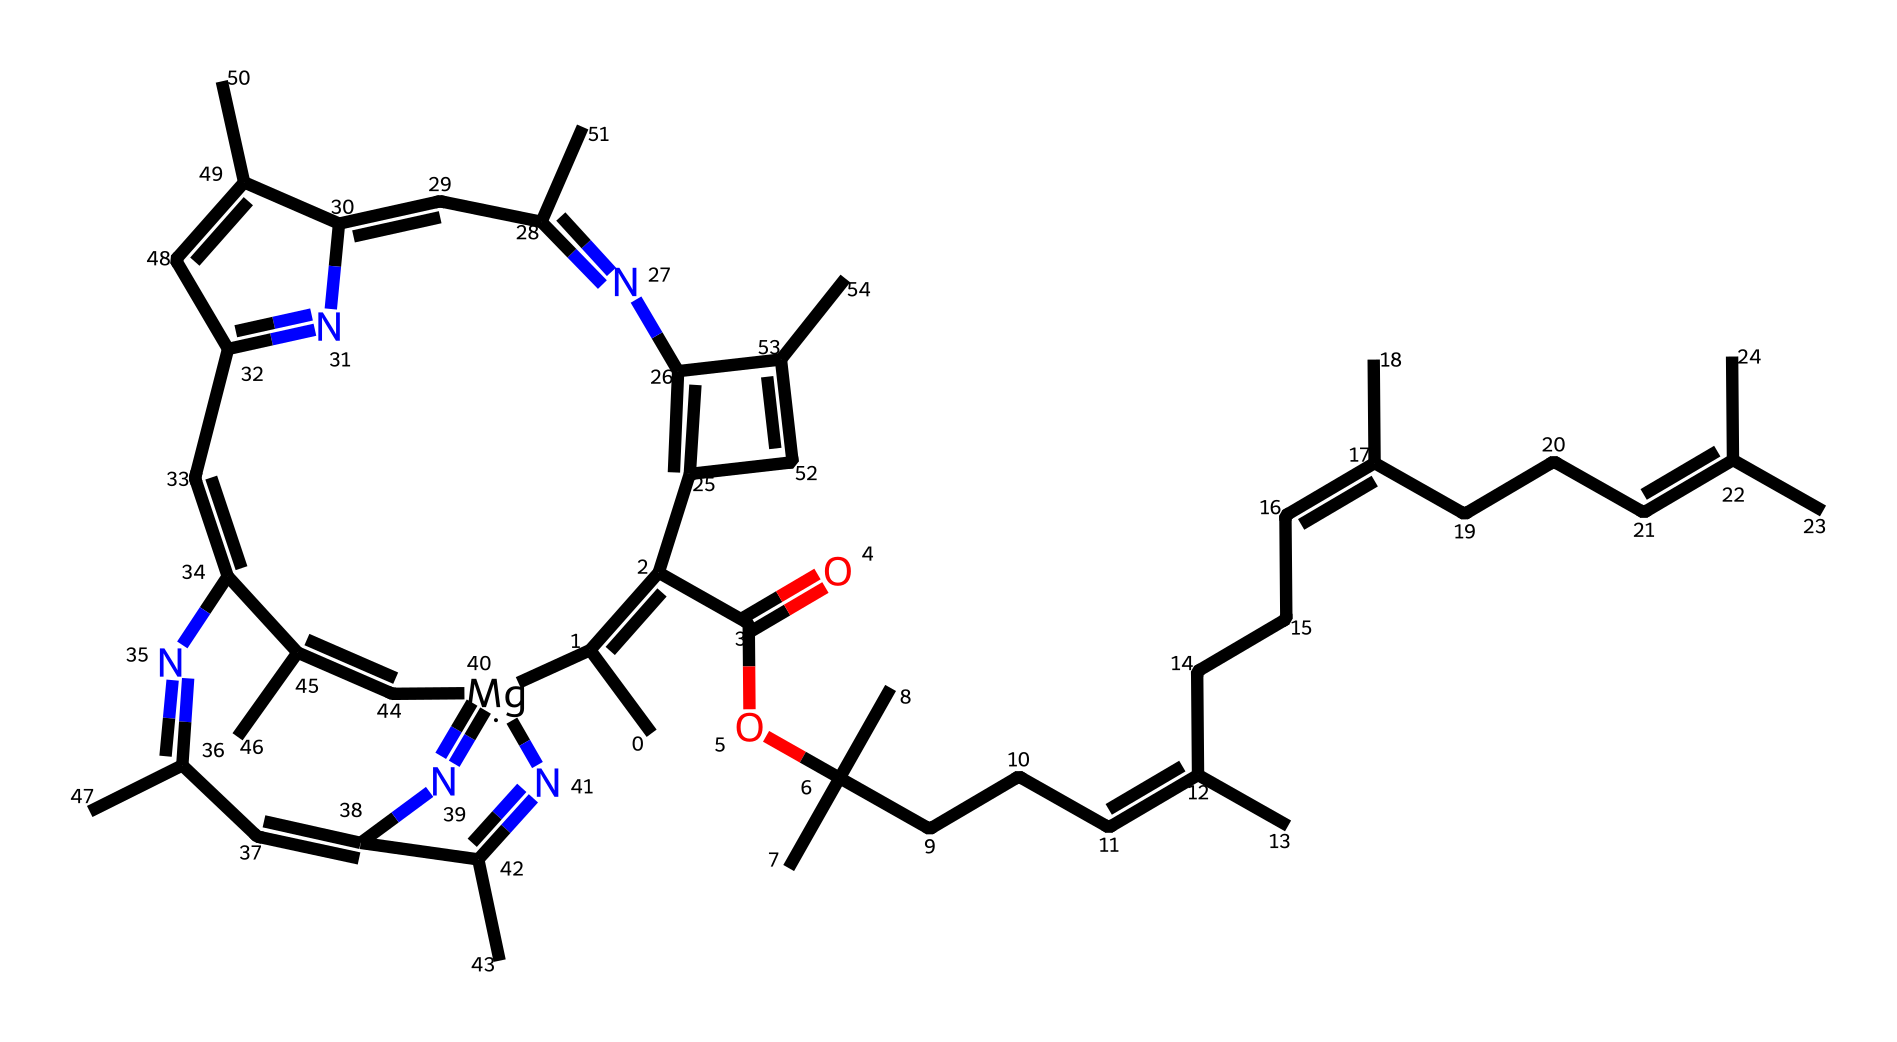What is the central metal atom in chlorophyll? The provided SMILES indicates that the central metal atom is magnesium, as evident from the notation "[Mg]" within the structure.
Answer: magnesium How many carbon atoms are in the chlorophyll structure? By analyzing the rendered chemical structure, one can count the number of carbon atoms represented. Upon inspection, there are a total of 55 carbon atoms in the entire molecule.
Answer: 55 What is the primary function of chlorophyll in plants? Chlorophyll serves to absorb light energy for photosynthesis, which is a crucial process for plant growth and energy production.
Answer: photosynthesis What type of coordination compound is chlorophyll classified as? Chlorophyll is classified as a metalloorganic coordination compound, which involves a metal ion coordinated to organic ligands.
Answer: metalloorganic How many nitrogen atoms are present in chlorophyll? By examining the structure closely, the total number of nitrogen atoms can be counted. In this case, there are 6 nitrogen atoms in the chlorophyll molecule.
Answer: 6 What is the significance of the magnesium center in chlorophyll? The magnesium center is essential as it stabilizes the chlorophyll structure and plays a crucial role in the absorption of light during photosynthesis.
Answer: stabilizes What type of structural feature allows chlorophyll to interact with light? The presence of conjugated double bonds (alternating single and double bonds) in the chlorophyll structure allows for effective light absorption and interaction, enabling the function of photosynthesis.
Answer: conjugated double bonds 